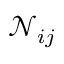Convert formula to latex. <formula><loc_0><loc_0><loc_500><loc_500>\mathcal { N } _ { i j }</formula> 